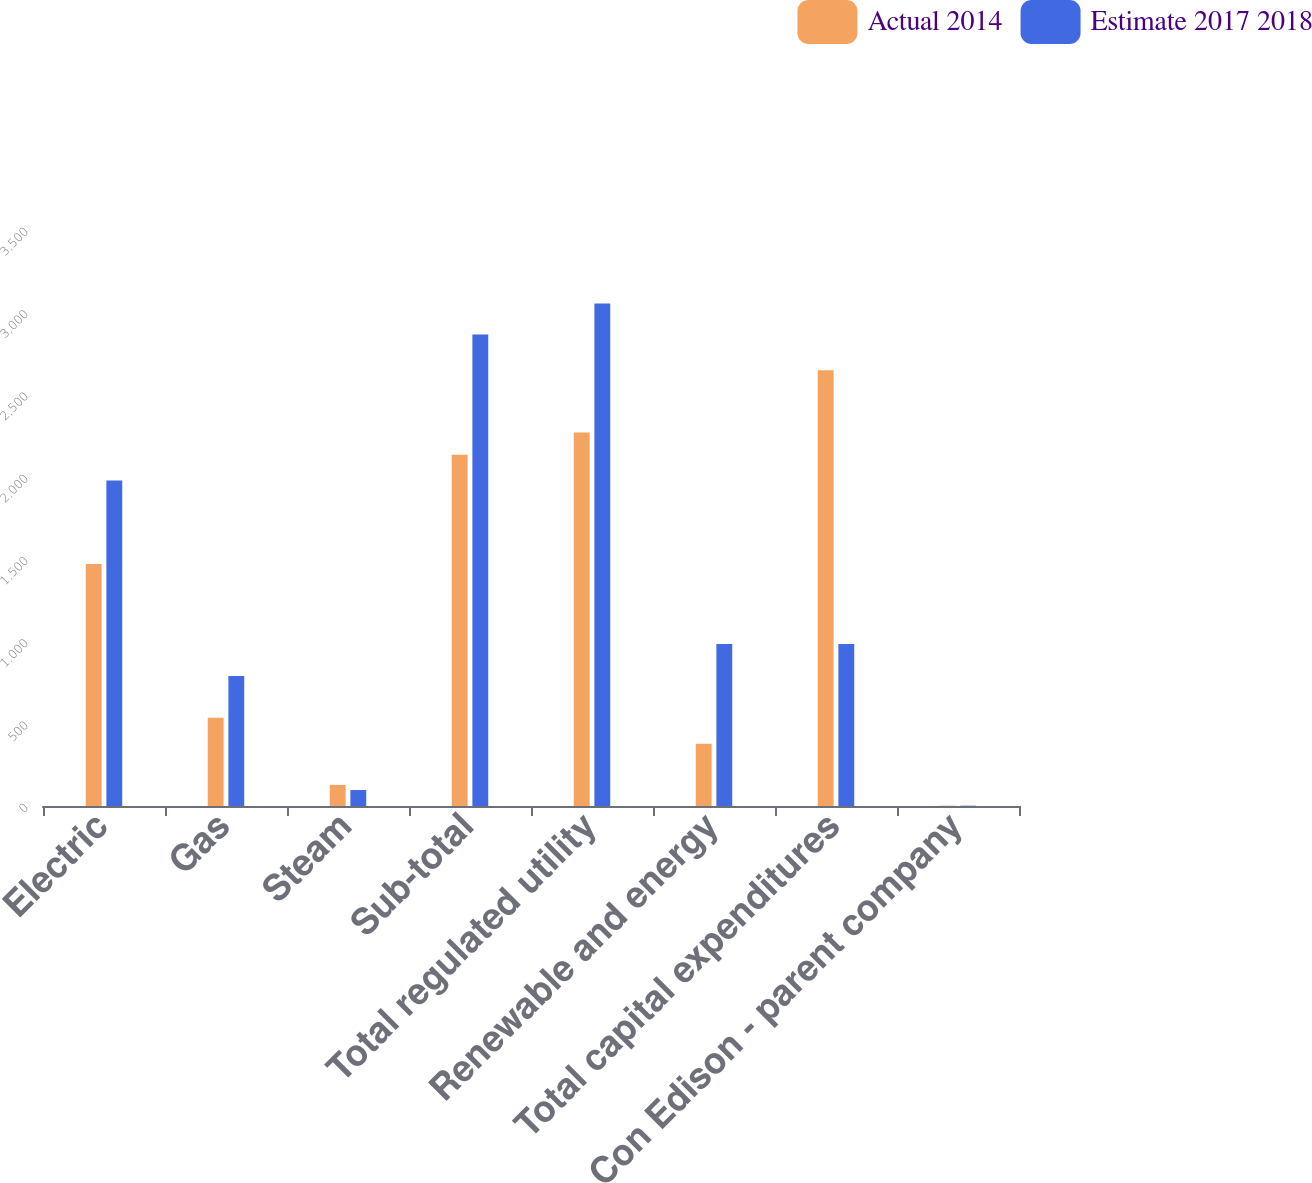Convert chart to OTSL. <chart><loc_0><loc_0><loc_500><loc_500><stacked_bar_chart><ecel><fcel>Electric<fcel>Gas<fcel>Steam<fcel>Sub-total<fcel>Total regulated utility<fcel>Renewable and energy<fcel>Total capital expenditures<fcel>Con Edison - parent company<nl><fcel>Actual 2014<fcel>1471<fcel>536<fcel>128<fcel>2135<fcel>2270<fcel>378<fcel>2648<fcel>2<nl><fcel>Estimate 2017 2018<fcel>1978<fcel>790<fcel>97<fcel>2865<fcel>3053<fcel>985<fcel>985<fcel>2<nl></chart> 